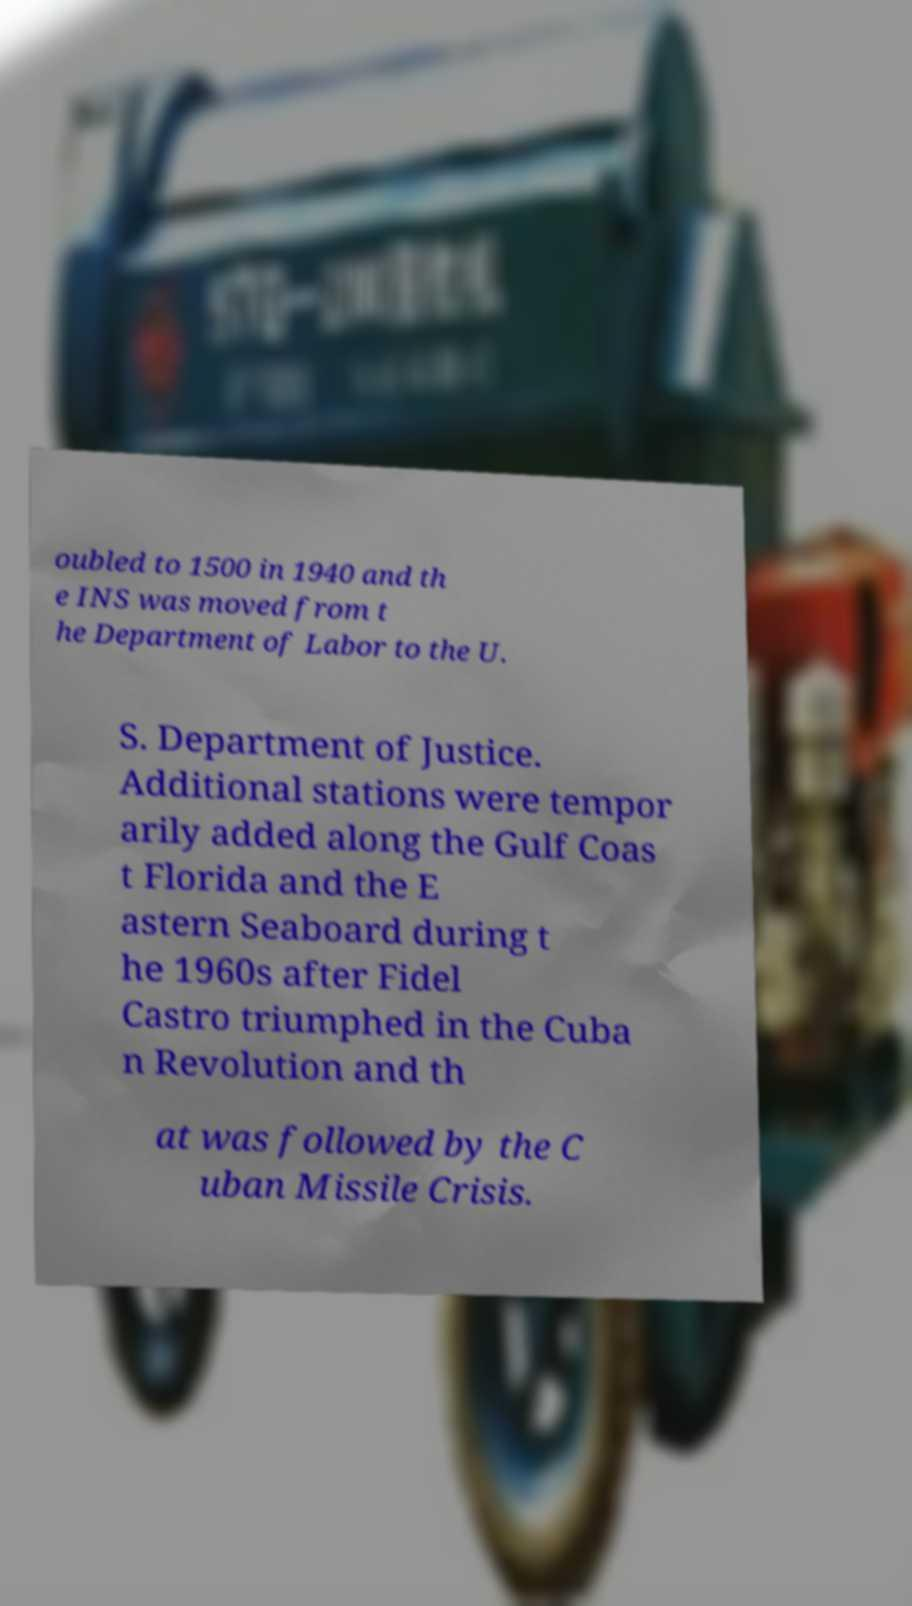What messages or text are displayed in this image? I need them in a readable, typed format. oubled to 1500 in 1940 and th e INS was moved from t he Department of Labor to the U. S. Department of Justice. Additional stations were tempor arily added along the Gulf Coas t Florida and the E astern Seaboard during t he 1960s after Fidel Castro triumphed in the Cuba n Revolution and th at was followed by the C uban Missile Crisis. 